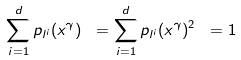<formula> <loc_0><loc_0><loc_500><loc_500>\sum _ { i = 1 } ^ { d } p _ { l ^ { i } } ( x ^ { \gamma } ) \ = \sum _ { i = 1 } ^ { d } p _ { l ^ { i } } ( x ^ { \gamma } ) ^ { 2 } \ = 1 \</formula> 